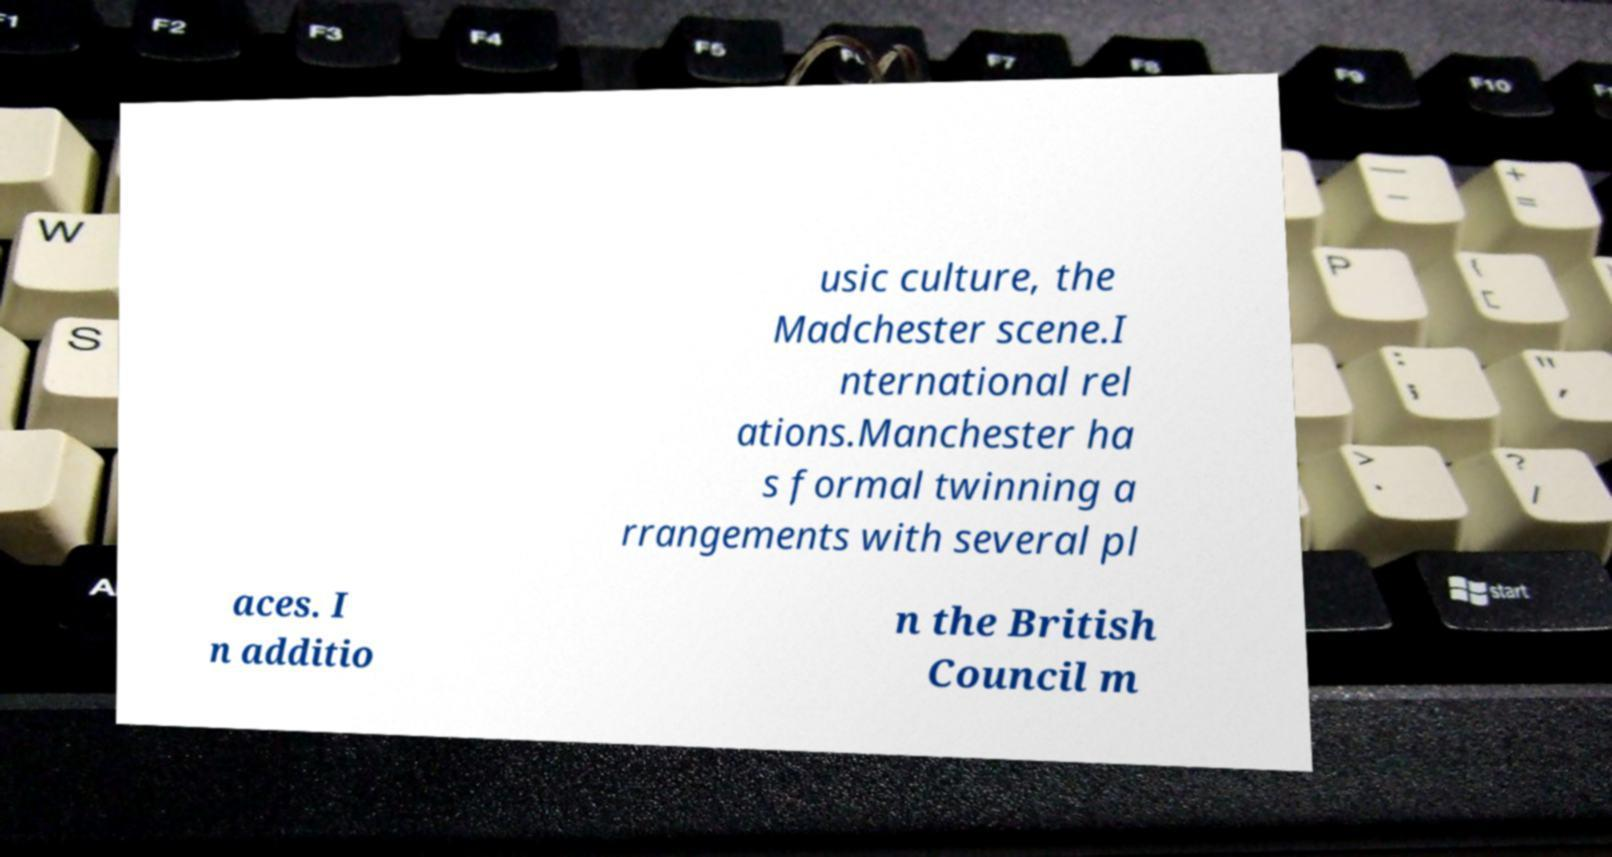For documentation purposes, I need the text within this image transcribed. Could you provide that? usic culture, the Madchester scene.I nternational rel ations.Manchester ha s formal twinning a rrangements with several pl aces. I n additio n the British Council m 